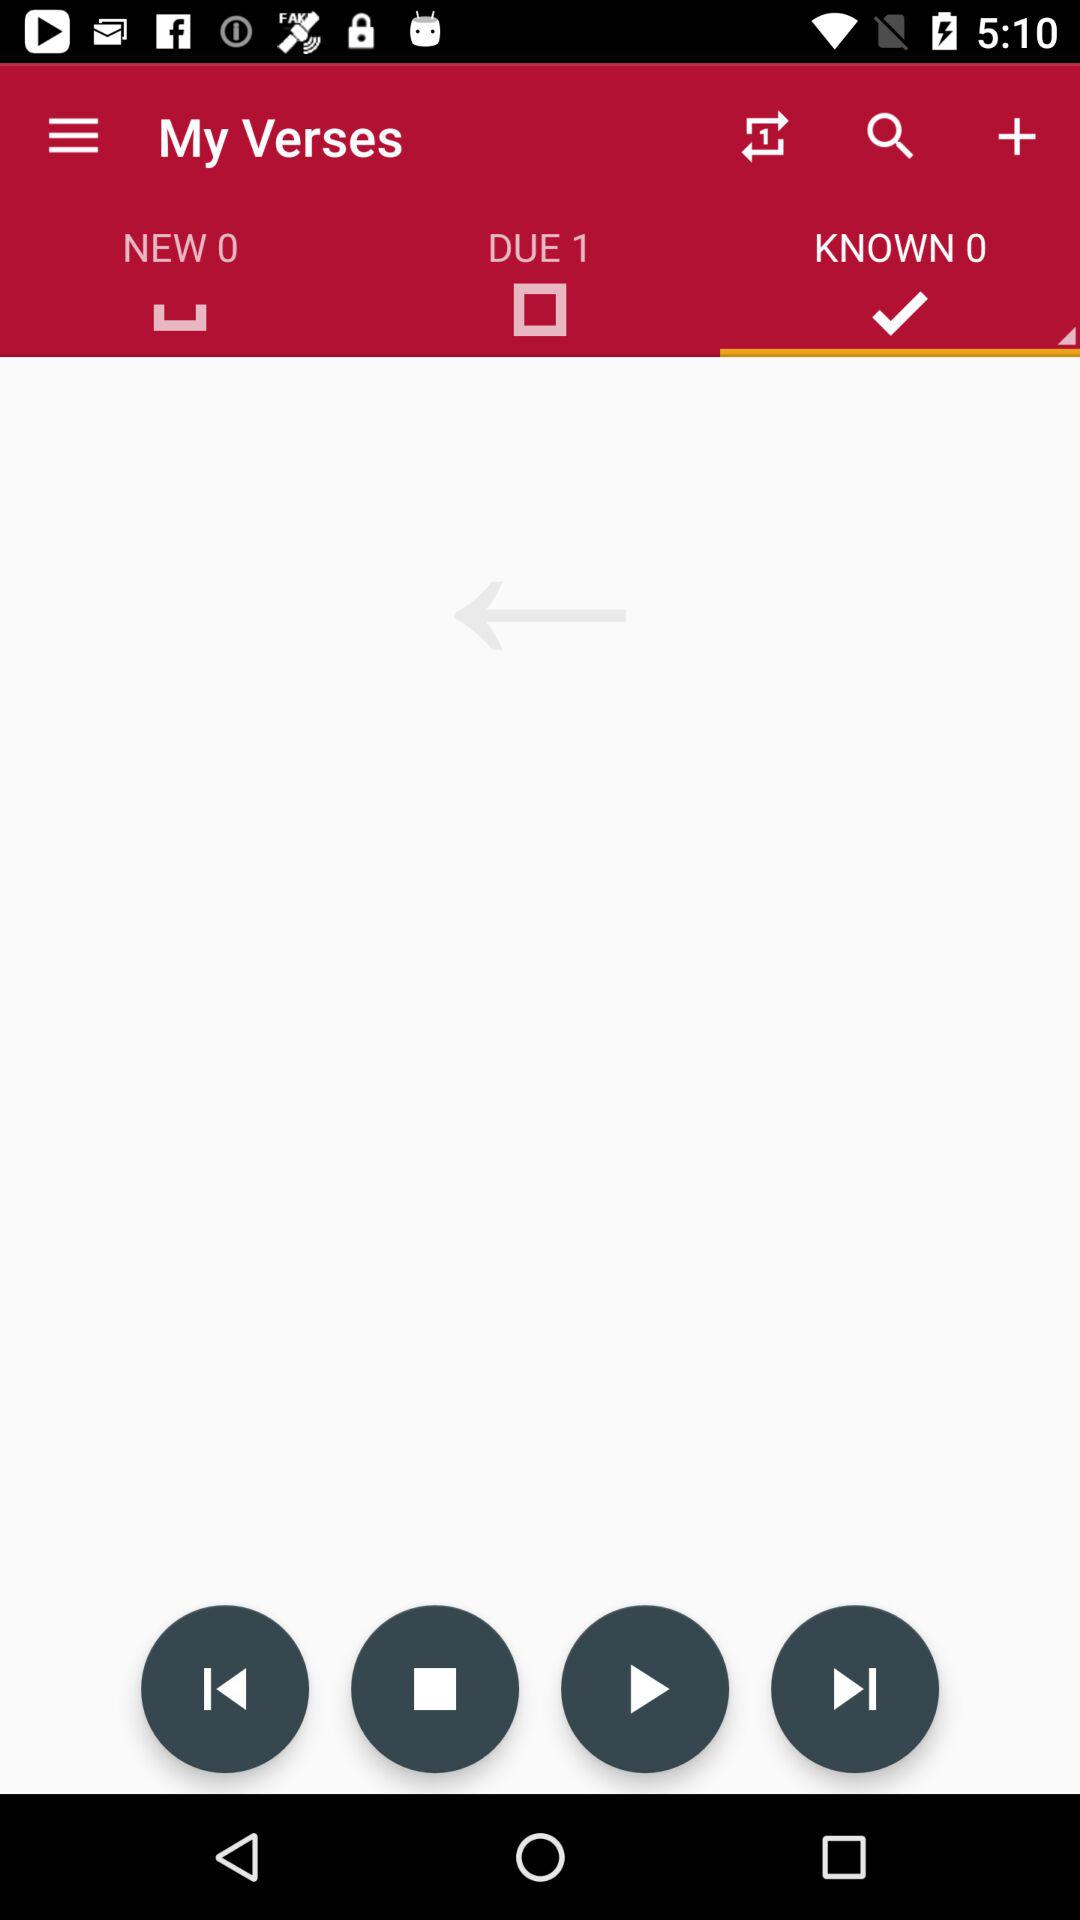What is the number count in "DUE"? The number count is 1. 